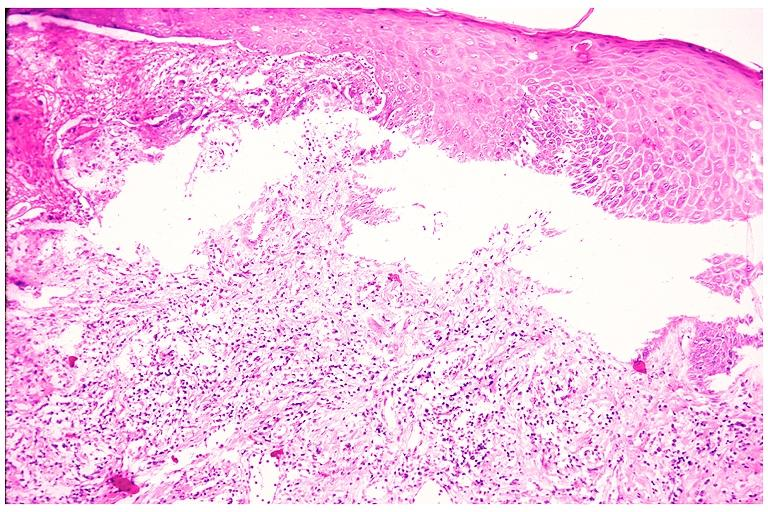s bone, skull present?
Answer the question using a single word or phrase. No 